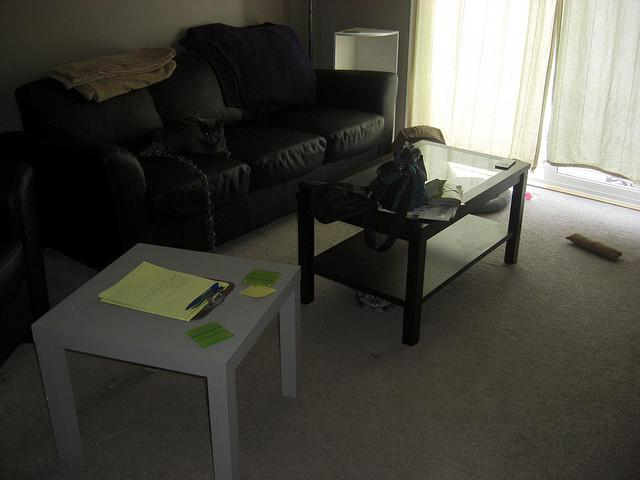What color has two post-its?

Choices:
A) orange
B) green
C) blue
D) yellow green 